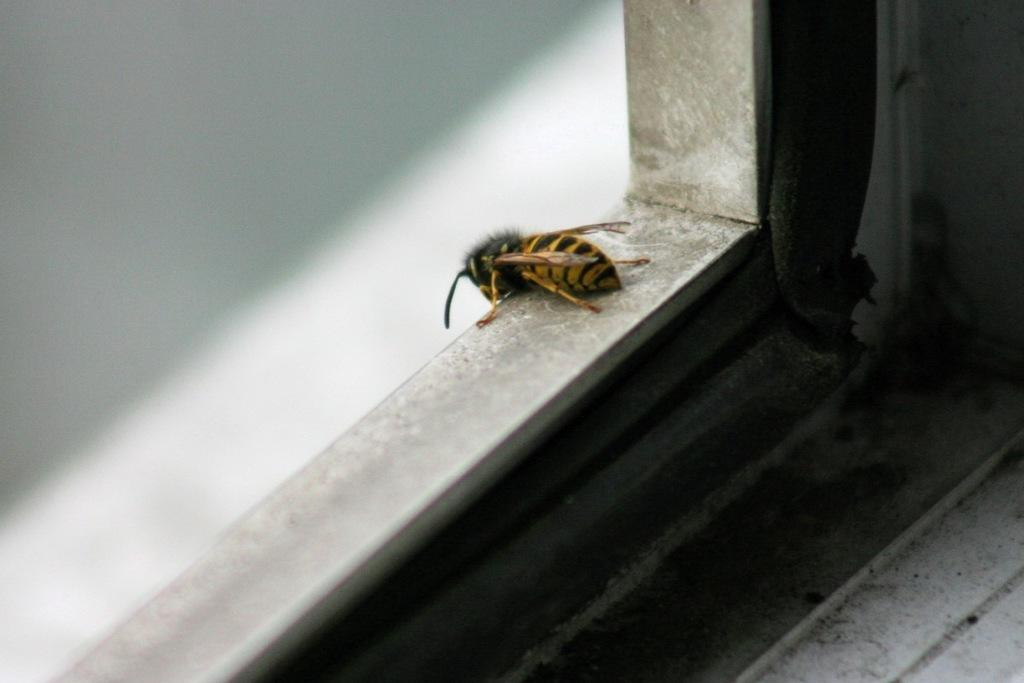What type of creature is present in the image? There is an insect in the image. Is the insect wearing a crown in the image? There is no mention of a crown or any other accessory in the image, so it cannot be determined if the insect is wearing one. 